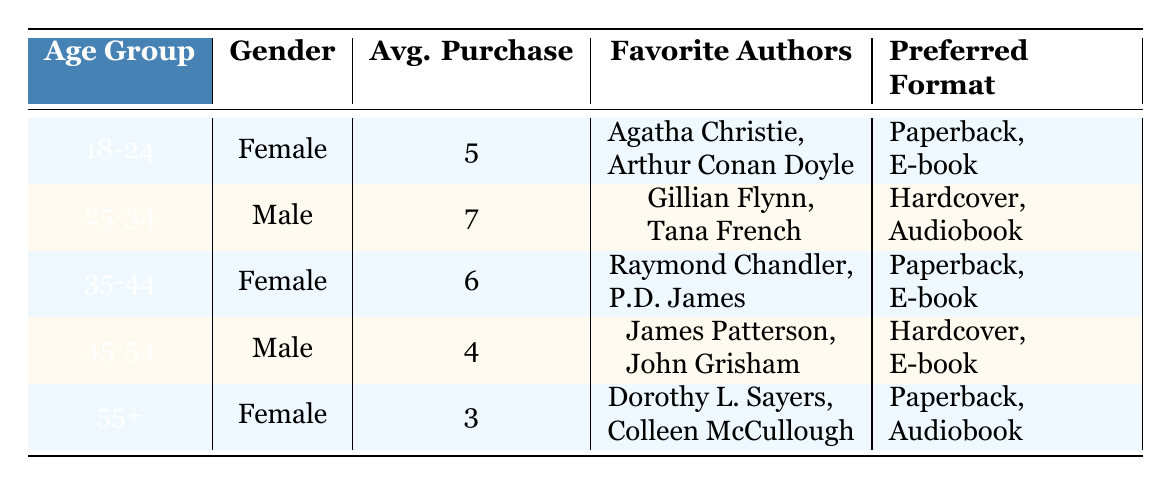What is the average purchase amount for the age group 25-34? The table indicates that the average purchase for the age group 25-34 is 7.
Answer: 7 Which gender has the highest average purchase amount? The average purchases are: Female (5, 6, 3) and Male (7, 4). The highest average purchase is for the Male category at 7.
Answer: Male Do customers aged 55 and above prefer audiobooks? The table shows that the preferred formats for the 55+ age group are Paperback and Audiobook. Therefore, they do prefer audiobooks.
Answer: Yes What are the favorite authors for the 35-44 age group? According to the table, the favorite authors for the 35-44 age group are Raymond Chandler and P.D. James.
Answer: Raymond Chandler, P.D. James What is the total average purchase for all age groups? To find the total average, sum the average purchases 5 + 7 + 6 + 4 + 3 = 25. There are 5 groups, so the average is 25 / 5 = 5.
Answer: 5 Which preferred formats do females aged 18-24 favor? The table shows that females in the age group 18-24 prefer Paperback and E-book.
Answer: Paperback, E-book Is there any age group that has an average purchase of less than 4? The age groups are 18-24 (5), 25-34 (7), 35-44 (6), 45-54 (4), and 55+ (3). The 55+ age group has an average purchase of 3, which is less than 4.
Answer: Yes What is the average purchase difference between the 25-34 and the 45-54 age groups? The average purchase for the 25-34 age group is 7, and for the 45-54 age group, it is 4. The difference is 7 - 4 = 3.
Answer: 3 Which age group has the least average purchases, and what is the amount? The table lists the average purchases: 5 (18-24), 7 (25-34), 6 (35-44), 4 (45-54), and 3 (55+). The least average purchase is 3, which belongs to the 55+ group.
Answer: 55+, 3 